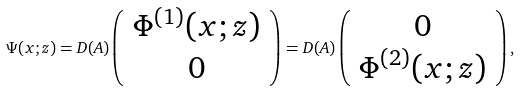Convert formula to latex. <formula><loc_0><loc_0><loc_500><loc_500>\Psi ( x ; z ) = D ( A ) \left ( \begin{array} { c r } \Phi ^ { ( 1 ) } ( x ; z ) \\ 0 \end{array} \right ) = D ( A ) \left ( \begin{array} { c r } 0 \\ \Phi ^ { ( 2 ) } ( x ; z ) \end{array} \right ) ,</formula> 